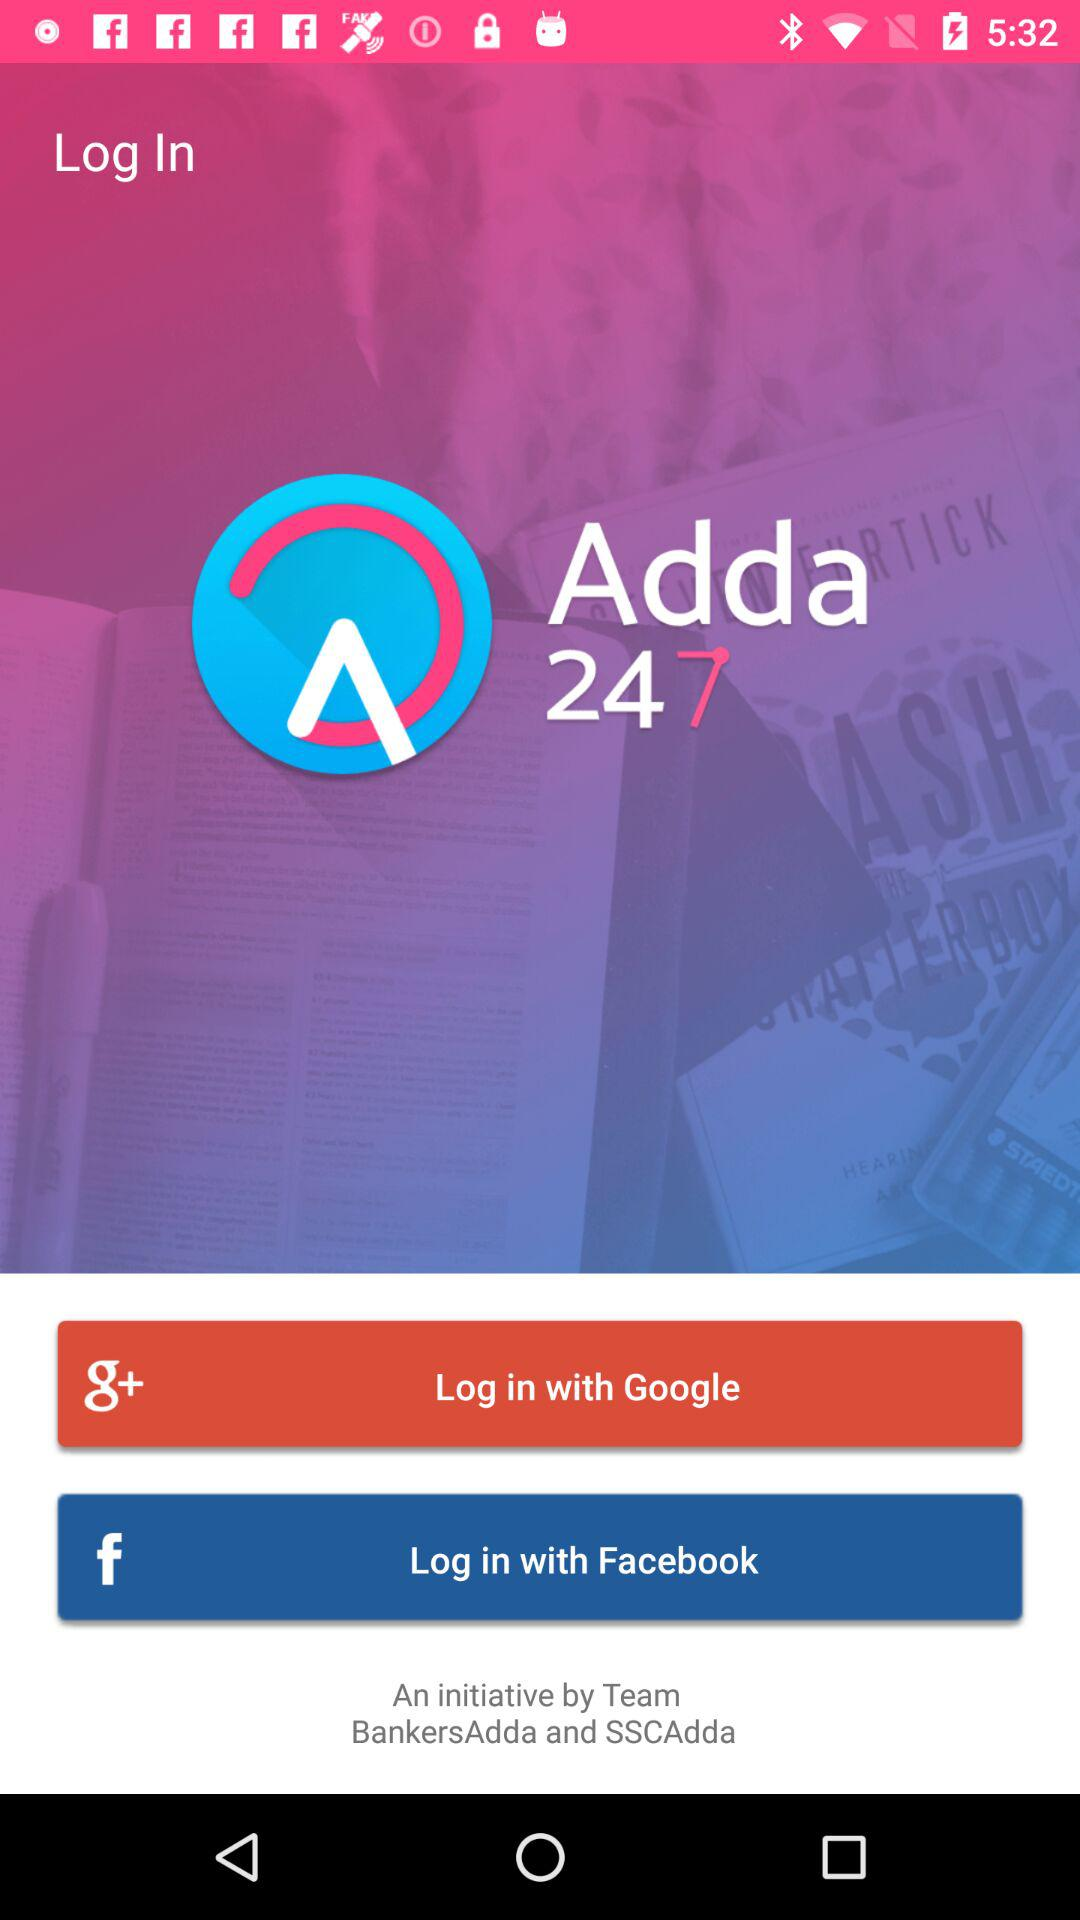What is the application name? The application name is "Adda 247". 